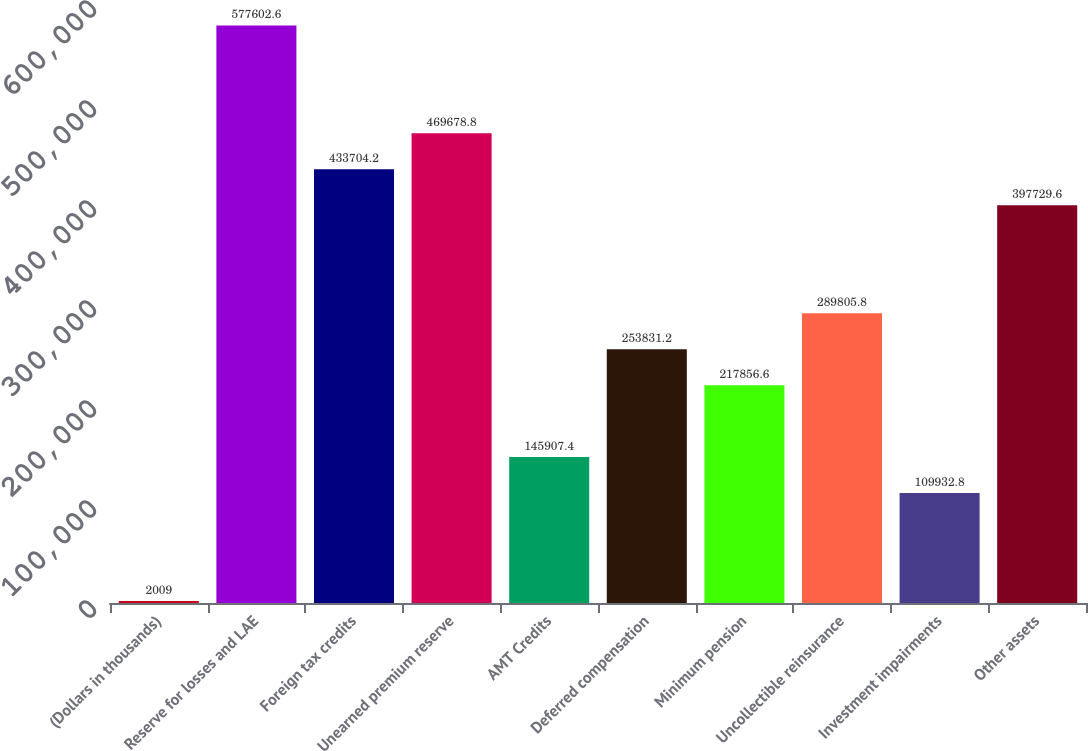<chart> <loc_0><loc_0><loc_500><loc_500><bar_chart><fcel>(Dollars in thousands)<fcel>Reserve for losses and LAE<fcel>Foreign tax credits<fcel>Unearned premium reserve<fcel>AMT Credits<fcel>Deferred compensation<fcel>Minimum pension<fcel>Uncollectible reinsurance<fcel>Investment impairments<fcel>Other assets<nl><fcel>2009<fcel>577603<fcel>433704<fcel>469679<fcel>145907<fcel>253831<fcel>217857<fcel>289806<fcel>109933<fcel>397730<nl></chart> 